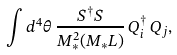Convert formula to latex. <formula><loc_0><loc_0><loc_500><loc_500>\int d ^ { 4 } \theta \, \frac { S ^ { \dagger } S } { M _ { * } ^ { 2 } ( M _ { * } L ) } \, Q _ { i } ^ { \dagger } \, Q _ { j } ,</formula> 